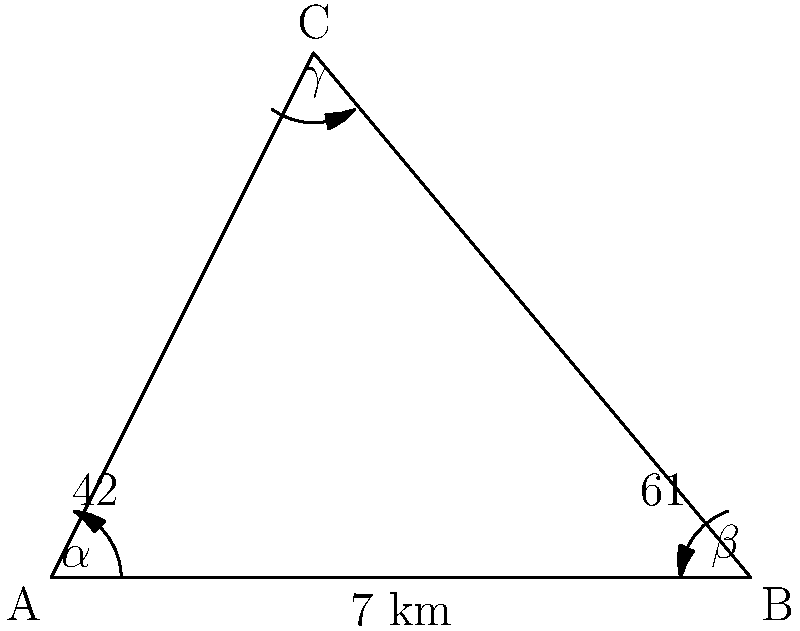Professor Urquhart once presented a fascinating problem involving non-right triangles. Consider the triangle ABC shown in the figure. If the distance between points A and B is 7 km, and angles $\alpha$ and $\beta$ are $42°$ and $61°$ respectively, what is the distance between points A and C? Round your answer to the nearest tenth of a kilometer. Let's approach this step-by-step, using the law of sines as Professor Urquhart taught us:

1) First, recall the law of sines: 
   $$\frac{a}{\sin A} = \frac{b}{\sin B} = \frac{c}{\sin C}$$

2) In our triangle:
   - Side c (AB) = 7 km
   - Angle $\alpha$ (A) = 42°
   - Angle $\beta$ (B) = 61°

3) We need to find side a (AC). Let's set up the proportion:
   $$\frac{a}{\sin 61°} = \frac{7}{\sin 42°}$$

4) We can solve this for a:
   $$a = \frac{7 \sin 61°}{\sin 42°}$$

5) Now, let's calculate:
   $$a = \frac{7 \times 0.8746}{0.6691} \approx 9.1492 \text{ km}$$

6) Rounding to the nearest tenth:
   $$a \approx 9.1 \text{ km}$$

Thus, the distance between points A and C is approximately 9.1 km.
Answer: 9.1 km 